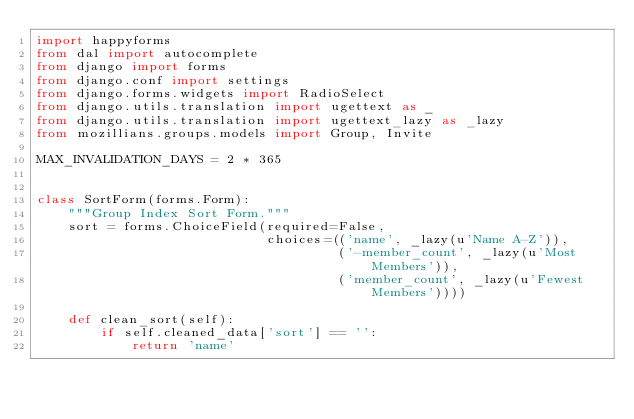Convert code to text. <code><loc_0><loc_0><loc_500><loc_500><_Python_>import happyforms
from dal import autocomplete
from django import forms
from django.conf import settings
from django.forms.widgets import RadioSelect
from django.utils.translation import ugettext as _
from django.utils.translation import ugettext_lazy as _lazy
from mozillians.groups.models import Group, Invite

MAX_INVALIDATION_DAYS = 2 * 365


class SortForm(forms.Form):
    """Group Index Sort Form."""
    sort = forms.ChoiceField(required=False,
                             choices=(('name', _lazy(u'Name A-Z')),
                                      ('-member_count', _lazy(u'Most Members')),
                                      ('member_count', _lazy(u'Fewest Members'))))

    def clean_sort(self):
        if self.cleaned_data['sort'] == '':
            return 'name'</code> 